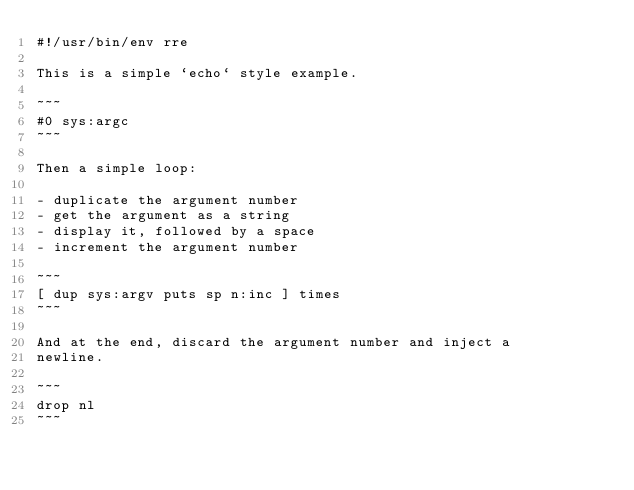<code> <loc_0><loc_0><loc_500><loc_500><_Forth_>#!/usr/bin/env rre

This is a simple `echo` style example.

~~~
#0 sys:argc
~~~

Then a simple loop:

- duplicate the argument number
- get the argument as a string
- display it, followed by a space
- increment the argument number

~~~
[ dup sys:argv puts sp n:inc ] times
~~~

And at the end, discard the argument number and inject a
newline.

~~~
drop nl
~~~
</code> 